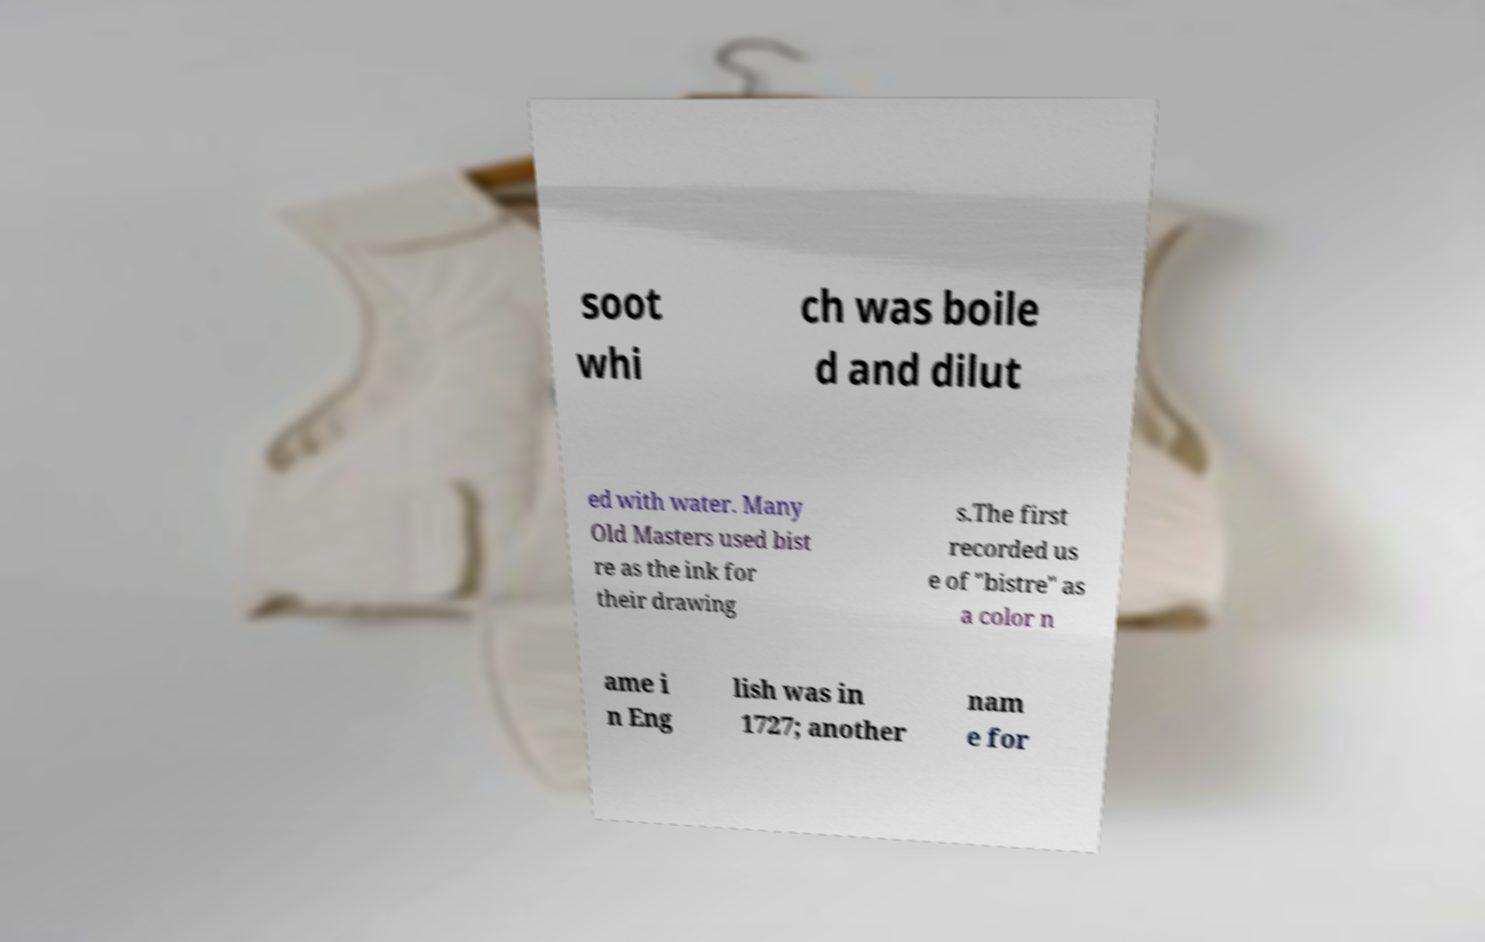Can you read and provide the text displayed in the image?This photo seems to have some interesting text. Can you extract and type it out for me? soot whi ch was boile d and dilut ed with water. Many Old Masters used bist re as the ink for their drawing s.The first recorded us e of "bistre" as a color n ame i n Eng lish was in 1727; another nam e for 